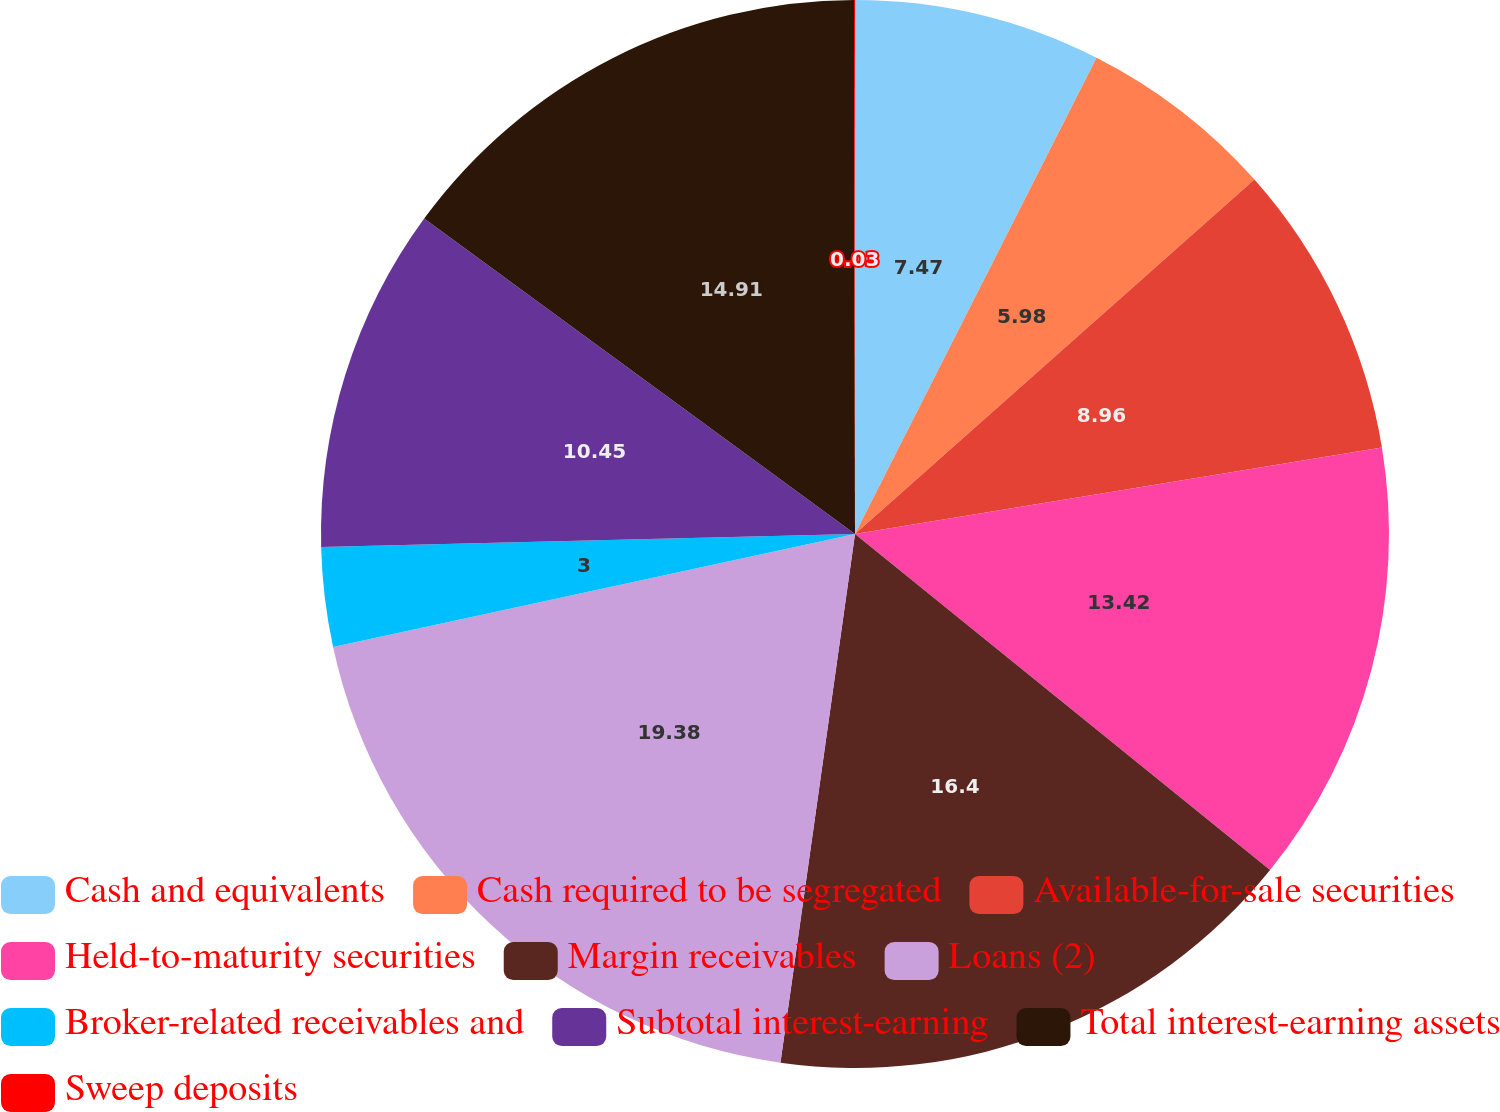<chart> <loc_0><loc_0><loc_500><loc_500><pie_chart><fcel>Cash and equivalents<fcel>Cash required to be segregated<fcel>Available-for-sale securities<fcel>Held-to-maturity securities<fcel>Margin receivables<fcel>Loans (2)<fcel>Broker-related receivables and<fcel>Subtotal interest-earning<fcel>Total interest-earning assets<fcel>Sweep deposits<nl><fcel>7.47%<fcel>5.98%<fcel>8.96%<fcel>13.42%<fcel>16.4%<fcel>19.38%<fcel>3.0%<fcel>10.45%<fcel>14.91%<fcel>0.03%<nl></chart> 